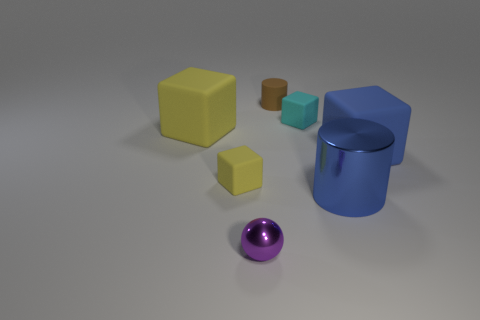Subtract all blue blocks. How many blocks are left? 3 Subtract all blue cylinders. How many yellow cubes are left? 2 Subtract 2 blocks. How many blocks are left? 2 Add 3 big purple rubber cubes. How many objects exist? 10 Subtract all cyan cubes. How many cubes are left? 3 Subtract all balls. How many objects are left? 6 Subtract all gray blocks. Subtract all gray cylinders. How many blocks are left? 4 Subtract all small brown metallic things. Subtract all cylinders. How many objects are left? 5 Add 1 tiny metal objects. How many tiny metal objects are left? 2 Add 6 small matte cylinders. How many small matte cylinders exist? 7 